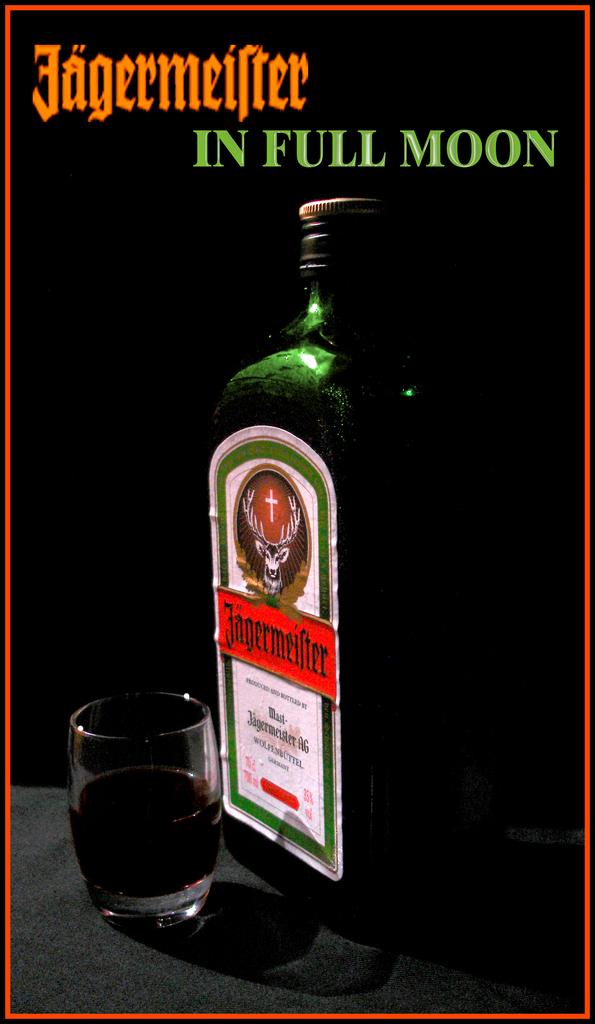What does it say in green at the top of this ad?
Your answer should be compact. In full moon. 